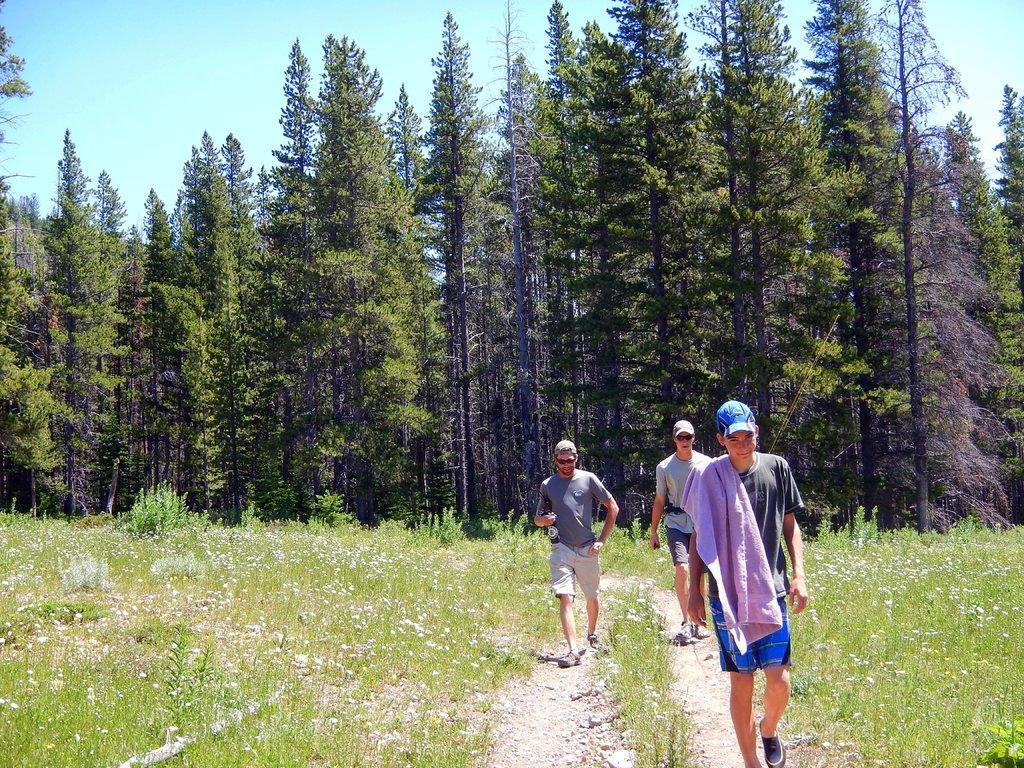Please provide a concise description of this image. In this picture there are three men walking on path and we can see plants, flowers and trees. In the background of the image we can see the sky. 